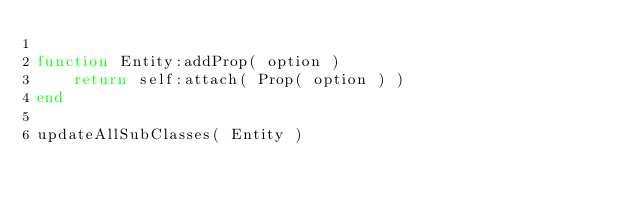Convert code to text. <code><loc_0><loc_0><loc_500><loc_500><_Lua_>
function Entity:addProp( option )
	return self:attach( Prop( option ) )
end

updateAllSubClasses( Entity )</code> 